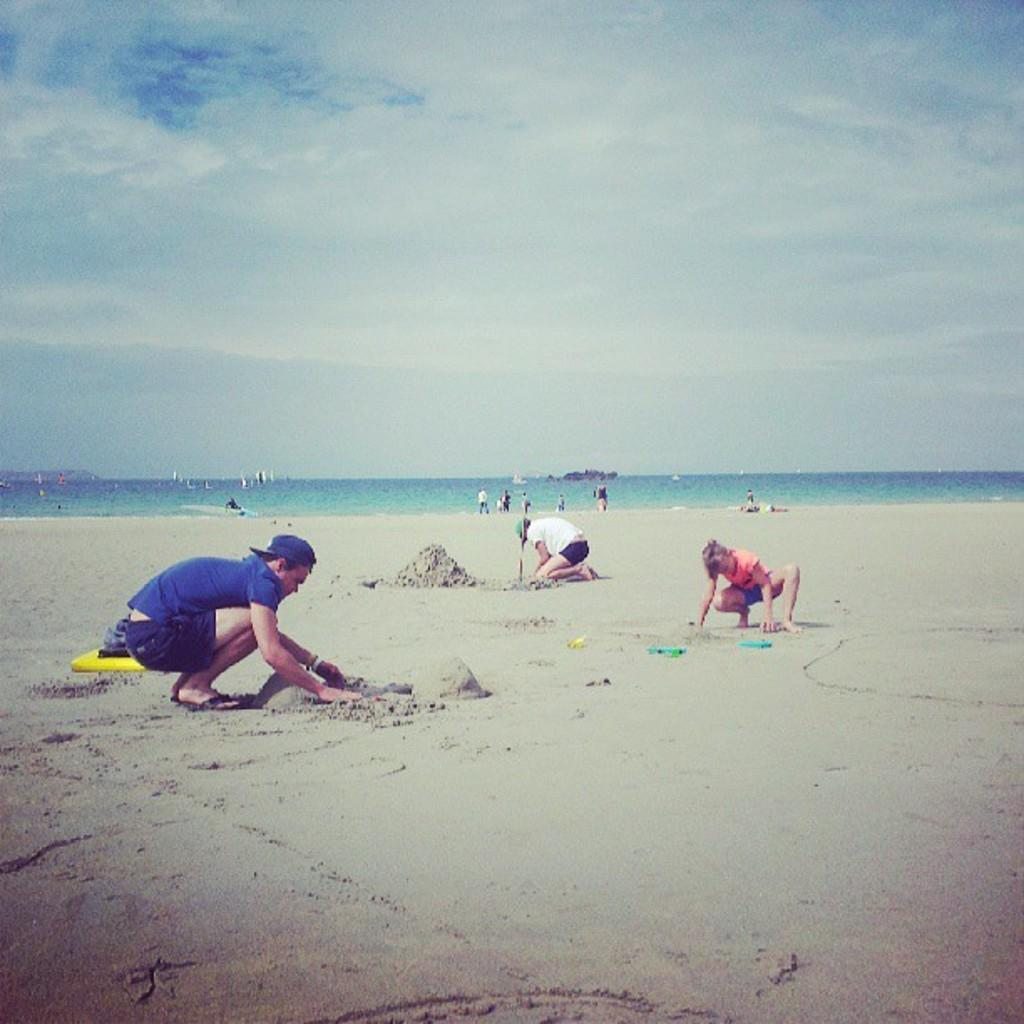What is the main setting of the image? There is a sea in the image. What are the people near the sea doing? Three people are playing with the sand near the sea, and there are people standing at the sea shore. What can be seen in the background of the image? The sky is visible in the background of the image. What type of meal is being prepared on the slope in the image? There is no slope or meal preparation present in the image; it features a sea with people near it and a visible sky in the background. 